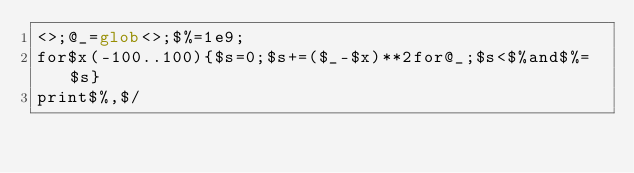<code> <loc_0><loc_0><loc_500><loc_500><_Perl_><>;@_=glob<>;$%=1e9;
for$x(-100..100){$s=0;$s+=($_-$x)**2for@_;$s<$%and$%=$s}
print$%,$/</code> 